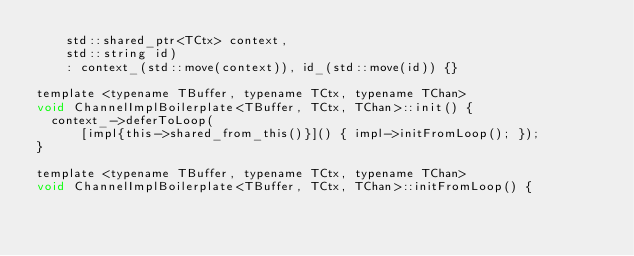<code> <loc_0><loc_0><loc_500><loc_500><_C_>    std::shared_ptr<TCtx> context,
    std::string id)
    : context_(std::move(context)), id_(std::move(id)) {}

template <typename TBuffer, typename TCtx, typename TChan>
void ChannelImplBoilerplate<TBuffer, TCtx, TChan>::init() {
  context_->deferToLoop(
      [impl{this->shared_from_this()}]() { impl->initFromLoop(); });
}

template <typename TBuffer, typename TCtx, typename TChan>
void ChannelImplBoilerplate<TBuffer, TCtx, TChan>::initFromLoop() {</code> 